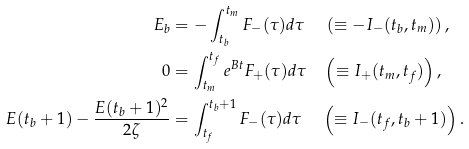<formula> <loc_0><loc_0><loc_500><loc_500>E _ { b } & = - \int _ { t _ { b } } ^ { t _ { m } } F _ { - } ( \tau ) d \tau \quad \, \left ( \equiv - I _ { - } ( t _ { b } , t _ { m } ) \right ) , \\ 0 & = \int _ { t _ { m } } ^ { t _ { f } } e ^ { B t } F _ { + } ( \tau ) d \tau \quad \left ( \equiv I _ { + } ( t _ { m } , t _ { f } ) \right ) , \\ E ( t _ { b } + 1 ) - \frac { E ( t _ { b } + 1 ) ^ { 2 } } { 2 \zeta } & = \int _ { t _ { f } } ^ { t _ { b } + 1 } F _ { - } ( \tau ) d \tau \quad \, \left ( \equiv I _ { - } ( t _ { f } , t _ { b } + 1 ) \right ) .</formula> 